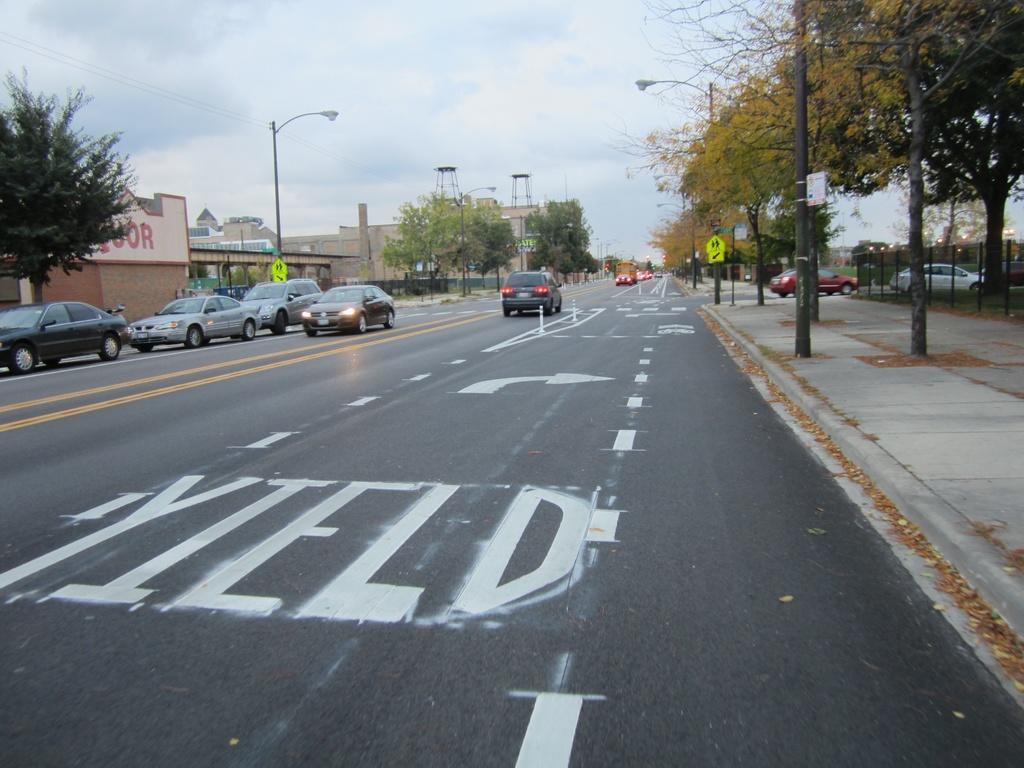Could you give a brief overview of what you see in this image? In this image we can see a road with direction sign and some text return on it. On the left side of the road we can see some cars parked and on the right side we can see the cars moving. We can see a footpath and trees on the right side of the image, to the left we can see a wall some text written on it, there is a pole beside the wall. 